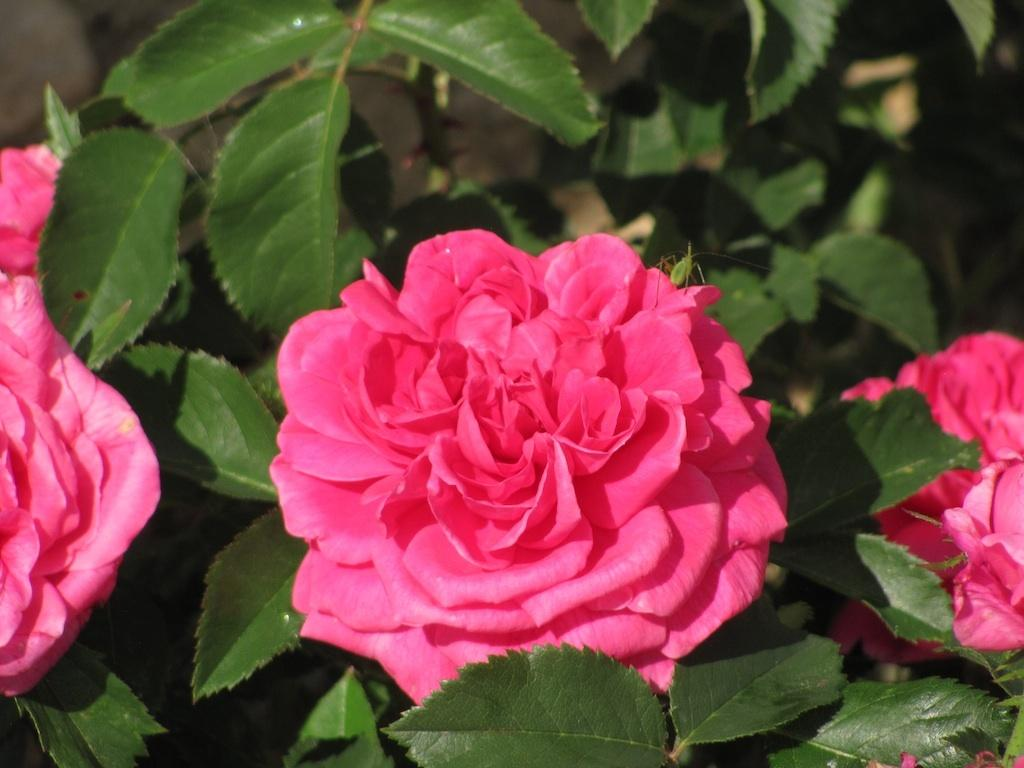What type of flowers are in the image? There are rose flowers in the image. What other type of plant can be seen in the image? There are plants in the image. What channel is the slave watching on the television in the image? There is no television or slave present in the image; it features rose flowers and plants. 